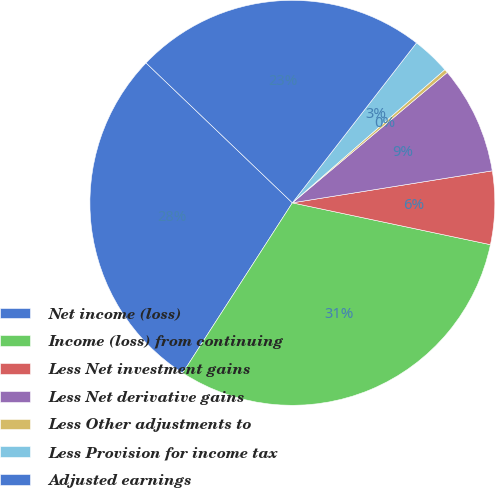Convert chart. <chart><loc_0><loc_0><loc_500><loc_500><pie_chart><fcel>Net income (loss)<fcel>Income (loss) from continuing<fcel>Less Net investment gains<fcel>Less Net derivative gains<fcel>Less Other adjustments to<fcel>Less Provision for income tax<fcel>Adjusted earnings<nl><fcel>28.03%<fcel>30.8%<fcel>5.84%<fcel>8.61%<fcel>0.29%<fcel>3.07%<fcel>23.36%<nl></chart> 